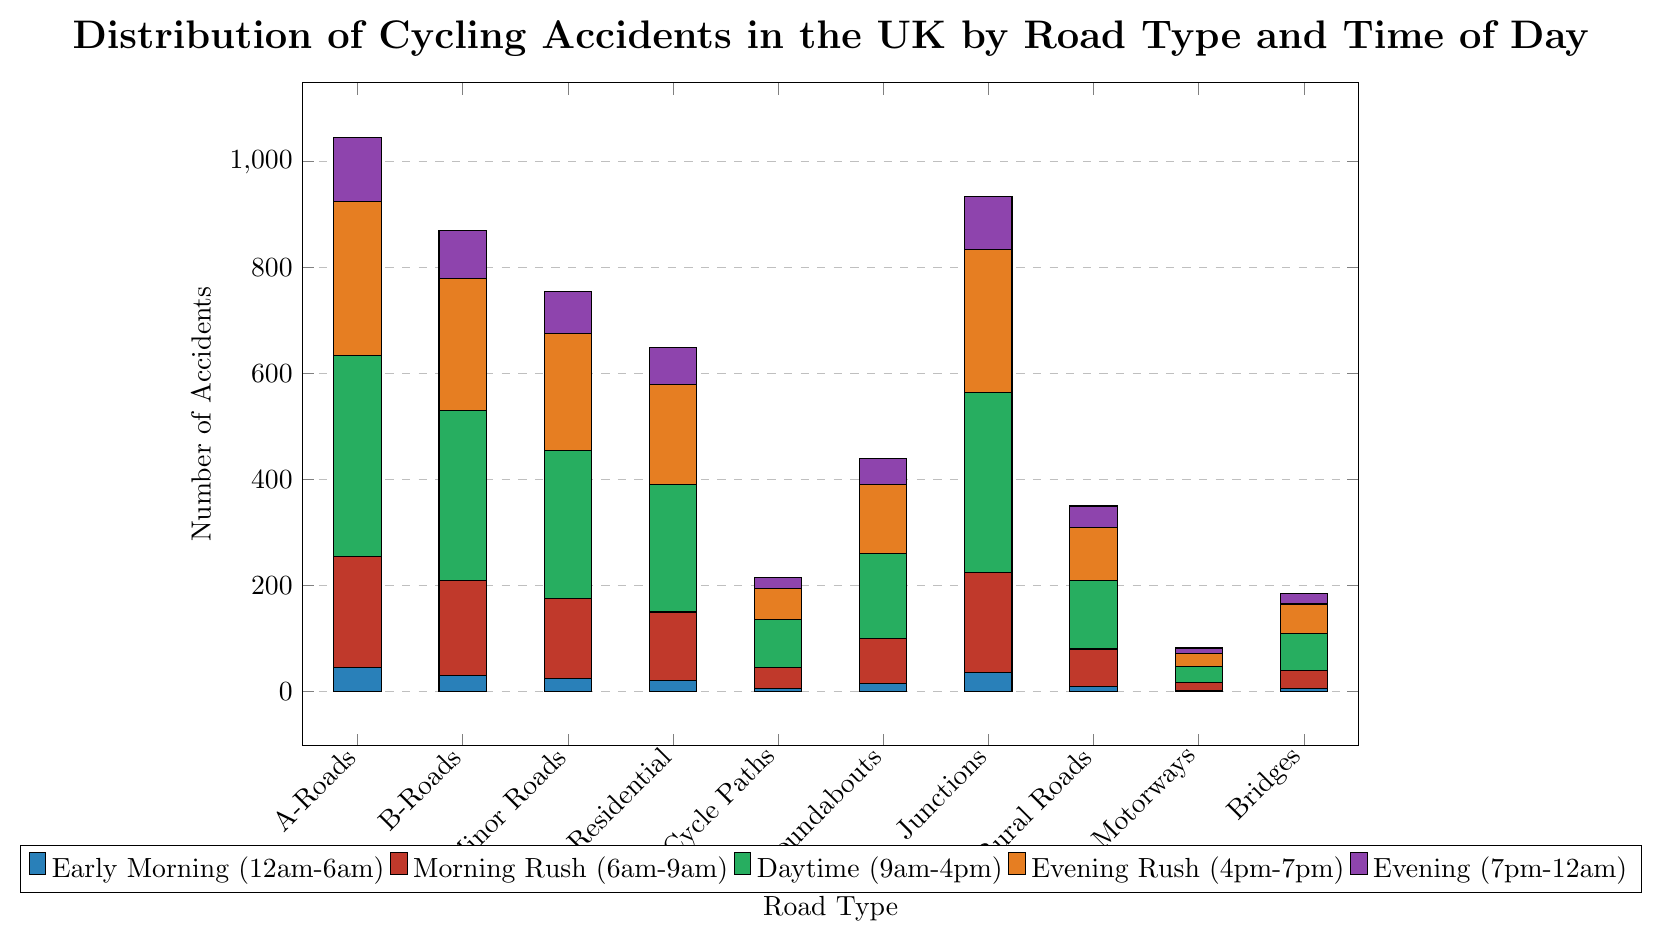What road type has the highest number of cycling accidents during the Daytime (9am-4pm)? Look for the tallest bar in the green section of the chart and identify the corresponding road type. Junctions have the tallest green bar.
Answer: Junctions How many total cycling accidents occur on B-Roads during Morning Rush (6am-9am) and Evening Rush (4pm-7pm)? Add up the values for B-Roads in the red bar (Morning Rush) and the orange bar (Evening Rush). 180 (Morning Rush) + 250 (Evening Rush) = 430.
Answer: 430 Which road type has the lowest number of cycling accidents during the Early Morning (12am-6am)? Identify the shortest bar in the blue section of the chart, which corresponds to the Early Morning category. Motorways have the shortest blue bar.
Answer: Motorways What is the combined number of cycling accidents on Cycle Paths across all times of the day? Sum the heights of all bars corresponding to Cycle Paths. 5 (Early Morning) + 40 (Morning Rush) + 90 (Daytime) + 60 (Evening Rush) + 20 (Evening) = 215.
Answer: 215 Are there more cycling accidents on Residential Streets or Rural Roads during Daytime (9am-4pm)? Compare the heights of the green bars for Residential Streets and Rural Roads. Residential Streets (240) are higher than Rural Roads (130).
Answer: Residential Streets How many more cycling accidents happen on Junctions compared to Roundabouts during the Evening Rush (4pm-7pm)? Subtract the number of Evening Rush (4pm-7pm) accidents on Roundabouts from those on Junctions. 270 (Junctions) - 130 (Roundabouts) = 140.
Answer: 140 Calculate the average number of cycling accidents during the Evening (7pm-12am) across all road types. Add up the number of Evening accidents across all road types and divide by the number of road types. (120 + 90 + 80 + 70 + 20 + 50 + 100 + 40 + 10 + 20) / 10 = 60.
Answer: 60 Which road type has a higher number of accidents in the Morning Rush (6am-9am), A-Roads or Minor Roads? Compare the heights of the red bars for A-Roads and Minor Roads. A-Roads (210) are higher than Minor Roads (150).
Answer: A-Roads On which Road Type does the number of cycling accidents decrease most consistently from Morning Rush (6am-9am) to Evening (7pm-12am)? Review how the bar heights decrease from red, green, orange to purple for each road type. Cycle Paths consistently decrease: 40 (Morning Rush) to 20 (Evening).
Answer: Cycle Paths 